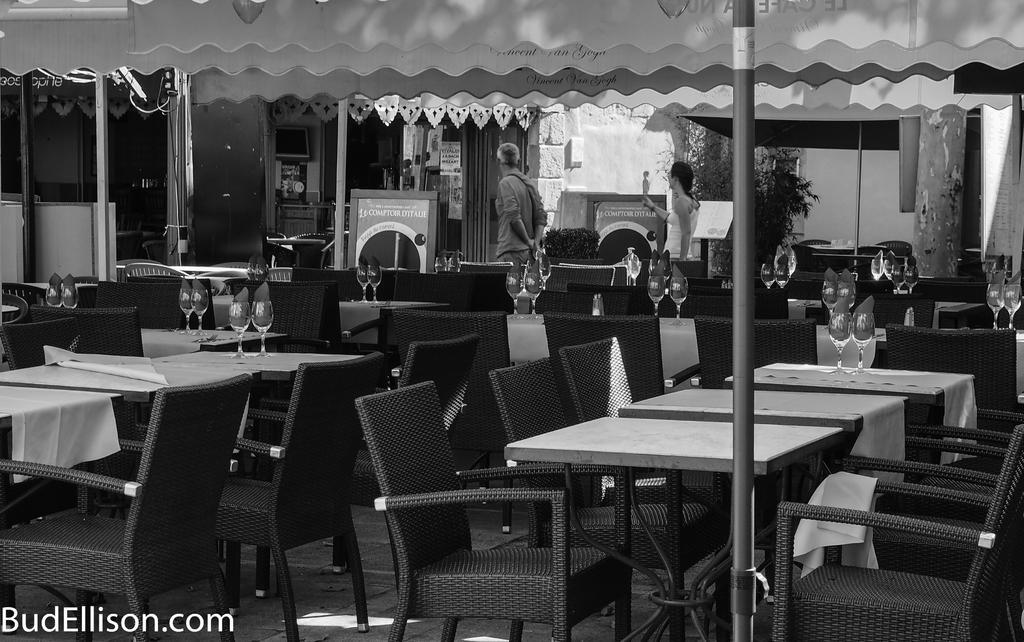Can you describe this image briefly? In this image we can see a few tables with chairs arrangement. Here we can see two persons who are walking and they are on the top center. 